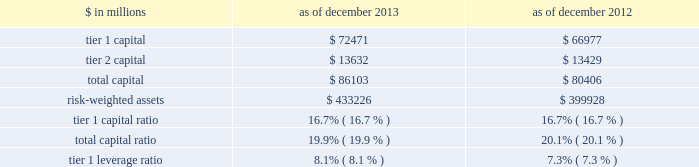Notes to consolidated financial statements the table below presents information regarding group inc . 2019s regulatory capital ratios and tier 1 leverage ratio under basel i , as implemented by the federal reserve board .
The information as of december 2013 reflects the revised market risk regulatory capital requirements .
These changes resulted in increased regulatory capital requirements for market risk .
The information as of december 2012 is prior to the implementation of these revised market risk regulatory capital requirements. .
Revised capital framework the u.s .
Federal bank regulatory agencies ( agencies ) have approved revised risk-based capital and leverage ratio regulations establishing a new comprehensive capital framework for u.s .
Banking organizations ( revised capital framework ) .
These regulations are largely based on the basel committee 2019s december 2010 final capital framework for strengthening international capital standards ( basel iii ) and also implement certain provisions of the dodd-frank act .
Under the revised capital framework , group inc .
Is an 201cadvanced approach 201d banking organization .
Below are the aspects of the rules that are most relevant to the firm , as an advanced approach banking organization .
Definition of capital and capital ratios .
The revised capital framework introduced changes to the definition of regulatory capital , which , subject to transitional provisions , became effective across the firm 2019s regulatory capital and leverage ratios on january 1 , 2014 .
These changes include the introduction of a new capital measure called common equity tier 1 ( cet1 ) , and the related regulatory capital ratio of cet1 to rwas ( cet1 ratio ) .
In addition , the definition of tier 1 capital has been narrowed to include only cet1 and instruments such as perpetual non- cumulative preferred stock , which meet certain criteria .
Certain aspects of the revised requirements phase in over time .
These include increases in the minimum capital ratio requirements and the introduction of new capital buffers and certain deductions from regulatory capital ( such as investments in nonconsolidated financial institutions ) .
In addition , junior subordinated debt issued to trusts is being phased out of regulatory capital .
The minimum cet1 ratio is 4.0% ( 4.0 % ) as of january 1 , 2014 and will increase to 4.5% ( 4.5 % ) on january 1 , 2015 .
The minimum tier 1 capital ratio increased from 4.0% ( 4.0 % ) to 5.5% ( 5.5 % ) on january 1 , 2014 and will increase to 6.0% ( 6.0 % ) beginning january 1 , 2015 .
The minimum total capital ratio remains unchanged at 8.0% ( 8.0 % ) .
These minimum ratios will be supplemented by a new capital conservation buffer that phases in , beginning january 1 , 2016 , in increments of 0.625% ( 0.625 % ) per year until it reaches 2.5% ( 2.5 % ) on january 1 , 2019 .
The revised capital framework also introduces a new counter-cyclical capital buffer , to be imposed in the event that national supervisors deem it necessary in order to counteract excessive credit growth .
Risk-weighted assets .
In february 2014 , the federal reserve board informed us that we have completed a satisfactory 201cparallel run , 201d as required of advanced approach banking organizations under the revised capital framework , and therefore changes to rwas will take effect beginning with the second quarter of 2014 .
Accordingly , the calculation of rwas in future quarters will be based on the following methodologies : 2030 during the first quarter of 2014 2014 the basel i risk-based capital framework adjusted for certain items related to existing capital deductions and the phase-in of new capital deductions ( basel i adjusted ) ; 2030 during the remaining quarters of 2014 2014 the higher of rwas computed under the basel iii advanced approach or the basel i adjusted calculation ; and 2030 beginning in the first quarter of 2015 2014 the higher of rwas computed under the basel iii advanced or standardized approach .
Goldman sachs 2013 annual report 191 .
What was the percentage change in tier 1 capital between 2012 and 2013? 
Computations: ((72471 - 66977) / 66977)
Answer: 0.08203. 